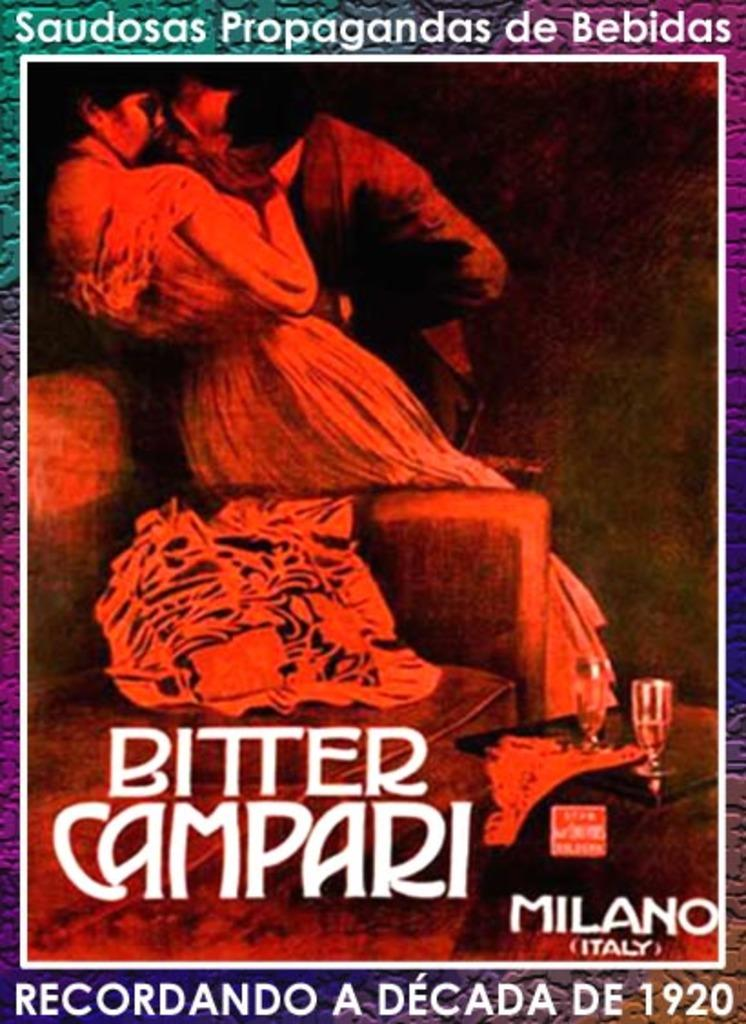<image>
Provide a brief description of the given image. a movie ad of a man kissing a woman up against a chair in Milano Italy 